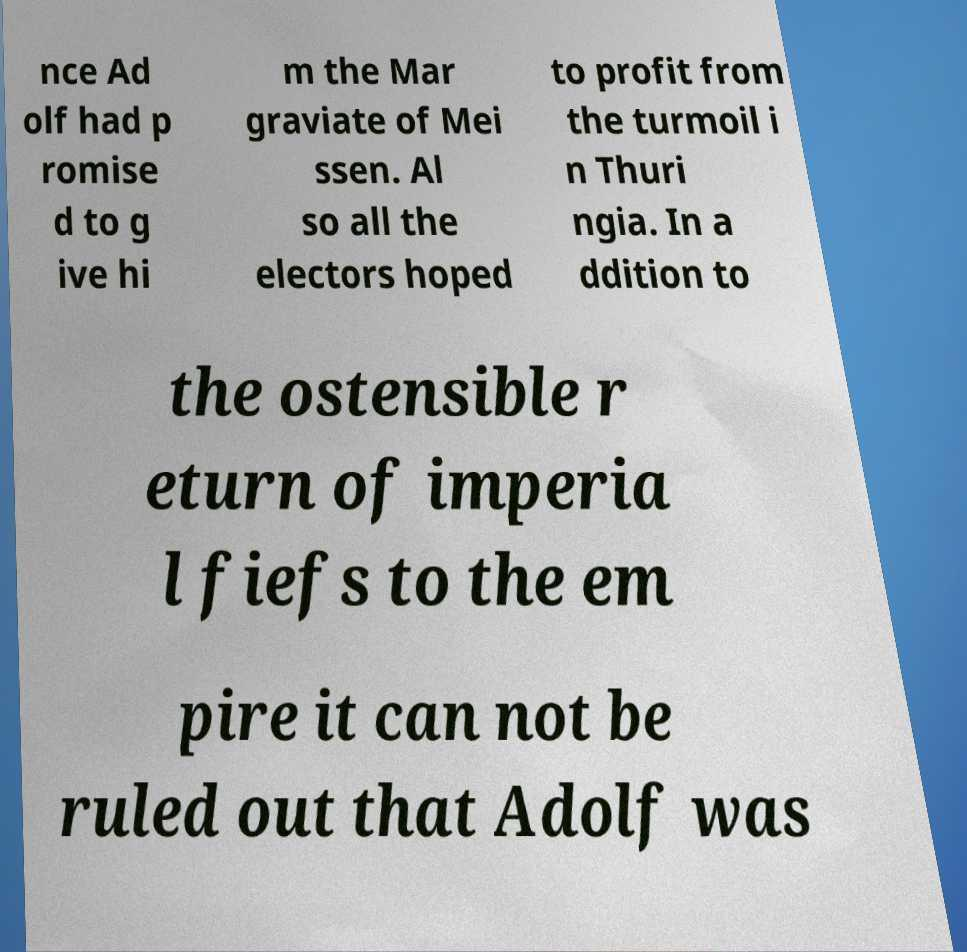For documentation purposes, I need the text within this image transcribed. Could you provide that? nce Ad olf had p romise d to g ive hi m the Mar graviate of Mei ssen. Al so all the electors hoped to profit from the turmoil i n Thuri ngia. In a ddition to the ostensible r eturn of imperia l fiefs to the em pire it can not be ruled out that Adolf was 